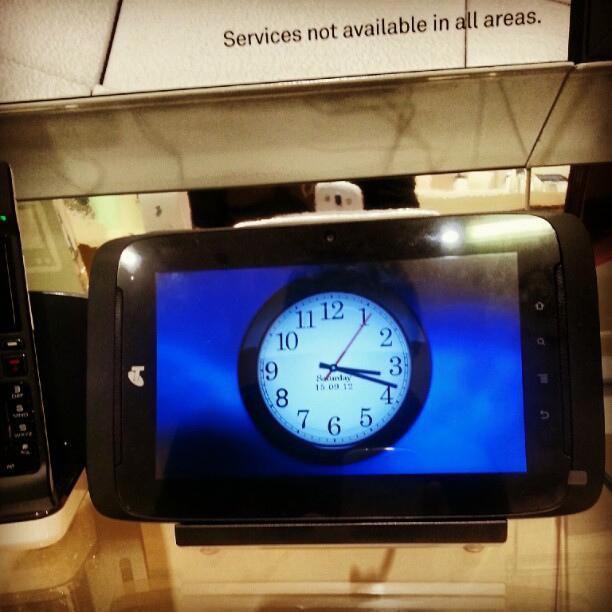How many cell phones are there?
Give a very brief answer. 2. How many people are wearing hats?
Give a very brief answer. 0. 